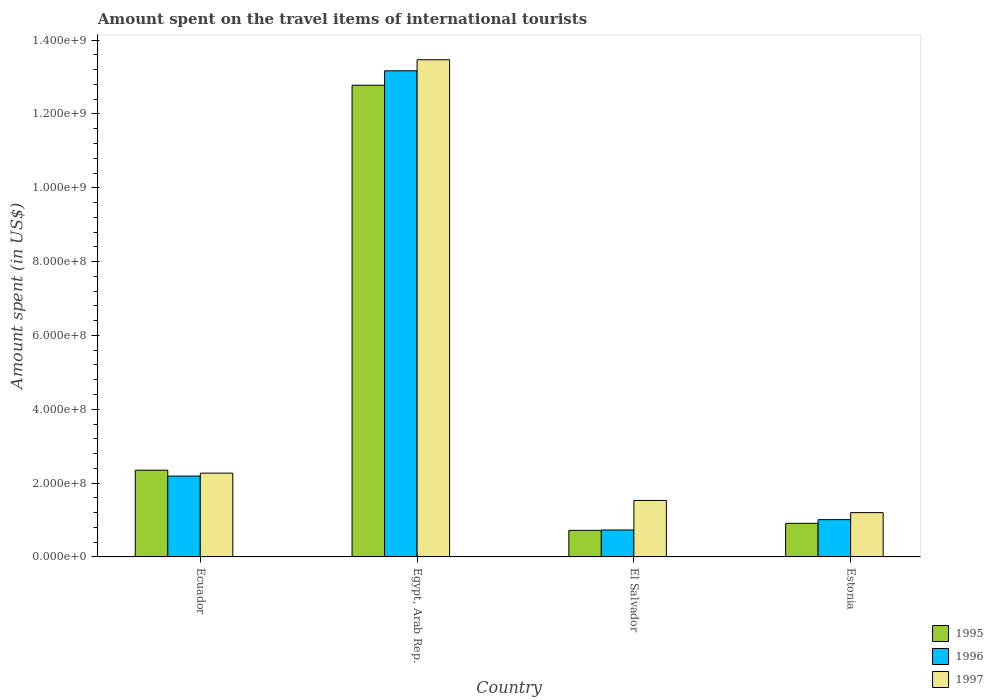How many different coloured bars are there?
Ensure brevity in your answer.  3. How many groups of bars are there?
Your response must be concise. 4. How many bars are there on the 2nd tick from the left?
Your response must be concise. 3. What is the label of the 2nd group of bars from the left?
Keep it short and to the point. Egypt, Arab Rep. In how many cases, is the number of bars for a given country not equal to the number of legend labels?
Keep it short and to the point. 0. What is the amount spent on the travel items of international tourists in 1997 in Egypt, Arab Rep.?
Ensure brevity in your answer.  1.35e+09. Across all countries, what is the maximum amount spent on the travel items of international tourists in 1997?
Make the answer very short. 1.35e+09. Across all countries, what is the minimum amount spent on the travel items of international tourists in 1995?
Give a very brief answer. 7.20e+07. In which country was the amount spent on the travel items of international tourists in 1997 maximum?
Your answer should be very brief. Egypt, Arab Rep. In which country was the amount spent on the travel items of international tourists in 1996 minimum?
Keep it short and to the point. El Salvador. What is the total amount spent on the travel items of international tourists in 1995 in the graph?
Offer a very short reply. 1.68e+09. What is the difference between the amount spent on the travel items of international tourists in 1995 in Egypt, Arab Rep. and that in Estonia?
Your response must be concise. 1.19e+09. What is the difference between the amount spent on the travel items of international tourists in 1996 in Egypt, Arab Rep. and the amount spent on the travel items of international tourists in 1997 in Ecuador?
Ensure brevity in your answer.  1.09e+09. What is the average amount spent on the travel items of international tourists in 1995 per country?
Your answer should be compact. 4.19e+08. What is the difference between the amount spent on the travel items of international tourists of/in 1995 and amount spent on the travel items of international tourists of/in 1997 in El Salvador?
Provide a succinct answer. -8.10e+07. In how many countries, is the amount spent on the travel items of international tourists in 1995 greater than 280000000 US$?
Give a very brief answer. 1. What is the ratio of the amount spent on the travel items of international tourists in 1996 in Ecuador to that in El Salvador?
Provide a succinct answer. 3. Is the amount spent on the travel items of international tourists in 1996 in Ecuador less than that in El Salvador?
Provide a short and direct response. No. Is the difference between the amount spent on the travel items of international tourists in 1995 in Egypt, Arab Rep. and El Salvador greater than the difference between the amount spent on the travel items of international tourists in 1997 in Egypt, Arab Rep. and El Salvador?
Make the answer very short. Yes. What is the difference between the highest and the second highest amount spent on the travel items of international tourists in 1995?
Make the answer very short. 1.19e+09. What is the difference between the highest and the lowest amount spent on the travel items of international tourists in 1996?
Provide a short and direct response. 1.24e+09. Is the sum of the amount spent on the travel items of international tourists in 1997 in Ecuador and Egypt, Arab Rep. greater than the maximum amount spent on the travel items of international tourists in 1996 across all countries?
Provide a succinct answer. Yes. Are all the bars in the graph horizontal?
Offer a terse response. No. How many countries are there in the graph?
Offer a very short reply. 4. Does the graph contain any zero values?
Keep it short and to the point. No. What is the title of the graph?
Provide a short and direct response. Amount spent on the travel items of international tourists. Does "1993" appear as one of the legend labels in the graph?
Keep it short and to the point. No. What is the label or title of the Y-axis?
Your answer should be very brief. Amount spent (in US$). What is the Amount spent (in US$) in 1995 in Ecuador?
Keep it short and to the point. 2.35e+08. What is the Amount spent (in US$) of 1996 in Ecuador?
Provide a short and direct response. 2.19e+08. What is the Amount spent (in US$) in 1997 in Ecuador?
Provide a succinct answer. 2.27e+08. What is the Amount spent (in US$) in 1995 in Egypt, Arab Rep.?
Your response must be concise. 1.28e+09. What is the Amount spent (in US$) in 1996 in Egypt, Arab Rep.?
Offer a very short reply. 1.32e+09. What is the Amount spent (in US$) in 1997 in Egypt, Arab Rep.?
Provide a short and direct response. 1.35e+09. What is the Amount spent (in US$) of 1995 in El Salvador?
Ensure brevity in your answer.  7.20e+07. What is the Amount spent (in US$) in 1996 in El Salvador?
Offer a terse response. 7.30e+07. What is the Amount spent (in US$) of 1997 in El Salvador?
Ensure brevity in your answer.  1.53e+08. What is the Amount spent (in US$) in 1995 in Estonia?
Offer a very short reply. 9.10e+07. What is the Amount spent (in US$) of 1996 in Estonia?
Ensure brevity in your answer.  1.01e+08. What is the Amount spent (in US$) of 1997 in Estonia?
Ensure brevity in your answer.  1.20e+08. Across all countries, what is the maximum Amount spent (in US$) of 1995?
Provide a short and direct response. 1.28e+09. Across all countries, what is the maximum Amount spent (in US$) in 1996?
Give a very brief answer. 1.32e+09. Across all countries, what is the maximum Amount spent (in US$) in 1997?
Offer a very short reply. 1.35e+09. Across all countries, what is the minimum Amount spent (in US$) in 1995?
Provide a succinct answer. 7.20e+07. Across all countries, what is the minimum Amount spent (in US$) of 1996?
Give a very brief answer. 7.30e+07. Across all countries, what is the minimum Amount spent (in US$) of 1997?
Offer a terse response. 1.20e+08. What is the total Amount spent (in US$) of 1995 in the graph?
Your answer should be compact. 1.68e+09. What is the total Amount spent (in US$) in 1996 in the graph?
Your answer should be very brief. 1.71e+09. What is the total Amount spent (in US$) in 1997 in the graph?
Keep it short and to the point. 1.85e+09. What is the difference between the Amount spent (in US$) in 1995 in Ecuador and that in Egypt, Arab Rep.?
Provide a short and direct response. -1.04e+09. What is the difference between the Amount spent (in US$) of 1996 in Ecuador and that in Egypt, Arab Rep.?
Your answer should be compact. -1.10e+09. What is the difference between the Amount spent (in US$) in 1997 in Ecuador and that in Egypt, Arab Rep.?
Ensure brevity in your answer.  -1.12e+09. What is the difference between the Amount spent (in US$) in 1995 in Ecuador and that in El Salvador?
Ensure brevity in your answer.  1.63e+08. What is the difference between the Amount spent (in US$) in 1996 in Ecuador and that in El Salvador?
Make the answer very short. 1.46e+08. What is the difference between the Amount spent (in US$) of 1997 in Ecuador and that in El Salvador?
Keep it short and to the point. 7.40e+07. What is the difference between the Amount spent (in US$) in 1995 in Ecuador and that in Estonia?
Offer a terse response. 1.44e+08. What is the difference between the Amount spent (in US$) of 1996 in Ecuador and that in Estonia?
Provide a succinct answer. 1.18e+08. What is the difference between the Amount spent (in US$) in 1997 in Ecuador and that in Estonia?
Give a very brief answer. 1.07e+08. What is the difference between the Amount spent (in US$) of 1995 in Egypt, Arab Rep. and that in El Salvador?
Provide a short and direct response. 1.21e+09. What is the difference between the Amount spent (in US$) of 1996 in Egypt, Arab Rep. and that in El Salvador?
Make the answer very short. 1.24e+09. What is the difference between the Amount spent (in US$) in 1997 in Egypt, Arab Rep. and that in El Salvador?
Make the answer very short. 1.19e+09. What is the difference between the Amount spent (in US$) in 1995 in Egypt, Arab Rep. and that in Estonia?
Provide a short and direct response. 1.19e+09. What is the difference between the Amount spent (in US$) in 1996 in Egypt, Arab Rep. and that in Estonia?
Give a very brief answer. 1.22e+09. What is the difference between the Amount spent (in US$) in 1997 in Egypt, Arab Rep. and that in Estonia?
Provide a succinct answer. 1.23e+09. What is the difference between the Amount spent (in US$) in 1995 in El Salvador and that in Estonia?
Offer a terse response. -1.90e+07. What is the difference between the Amount spent (in US$) in 1996 in El Salvador and that in Estonia?
Provide a short and direct response. -2.80e+07. What is the difference between the Amount spent (in US$) of 1997 in El Salvador and that in Estonia?
Your response must be concise. 3.30e+07. What is the difference between the Amount spent (in US$) in 1995 in Ecuador and the Amount spent (in US$) in 1996 in Egypt, Arab Rep.?
Give a very brief answer. -1.08e+09. What is the difference between the Amount spent (in US$) in 1995 in Ecuador and the Amount spent (in US$) in 1997 in Egypt, Arab Rep.?
Provide a succinct answer. -1.11e+09. What is the difference between the Amount spent (in US$) of 1996 in Ecuador and the Amount spent (in US$) of 1997 in Egypt, Arab Rep.?
Offer a very short reply. -1.13e+09. What is the difference between the Amount spent (in US$) of 1995 in Ecuador and the Amount spent (in US$) of 1996 in El Salvador?
Provide a succinct answer. 1.62e+08. What is the difference between the Amount spent (in US$) of 1995 in Ecuador and the Amount spent (in US$) of 1997 in El Salvador?
Provide a succinct answer. 8.20e+07. What is the difference between the Amount spent (in US$) of 1996 in Ecuador and the Amount spent (in US$) of 1997 in El Salvador?
Give a very brief answer. 6.60e+07. What is the difference between the Amount spent (in US$) in 1995 in Ecuador and the Amount spent (in US$) in 1996 in Estonia?
Your response must be concise. 1.34e+08. What is the difference between the Amount spent (in US$) in 1995 in Ecuador and the Amount spent (in US$) in 1997 in Estonia?
Your answer should be compact. 1.15e+08. What is the difference between the Amount spent (in US$) of 1996 in Ecuador and the Amount spent (in US$) of 1997 in Estonia?
Your answer should be very brief. 9.90e+07. What is the difference between the Amount spent (in US$) of 1995 in Egypt, Arab Rep. and the Amount spent (in US$) of 1996 in El Salvador?
Give a very brief answer. 1.20e+09. What is the difference between the Amount spent (in US$) in 1995 in Egypt, Arab Rep. and the Amount spent (in US$) in 1997 in El Salvador?
Make the answer very short. 1.12e+09. What is the difference between the Amount spent (in US$) of 1996 in Egypt, Arab Rep. and the Amount spent (in US$) of 1997 in El Salvador?
Ensure brevity in your answer.  1.16e+09. What is the difference between the Amount spent (in US$) of 1995 in Egypt, Arab Rep. and the Amount spent (in US$) of 1996 in Estonia?
Your answer should be compact. 1.18e+09. What is the difference between the Amount spent (in US$) in 1995 in Egypt, Arab Rep. and the Amount spent (in US$) in 1997 in Estonia?
Give a very brief answer. 1.16e+09. What is the difference between the Amount spent (in US$) in 1996 in Egypt, Arab Rep. and the Amount spent (in US$) in 1997 in Estonia?
Provide a short and direct response. 1.20e+09. What is the difference between the Amount spent (in US$) in 1995 in El Salvador and the Amount spent (in US$) in 1996 in Estonia?
Your answer should be compact. -2.90e+07. What is the difference between the Amount spent (in US$) of 1995 in El Salvador and the Amount spent (in US$) of 1997 in Estonia?
Offer a very short reply. -4.80e+07. What is the difference between the Amount spent (in US$) in 1996 in El Salvador and the Amount spent (in US$) in 1997 in Estonia?
Make the answer very short. -4.70e+07. What is the average Amount spent (in US$) of 1995 per country?
Your answer should be compact. 4.19e+08. What is the average Amount spent (in US$) of 1996 per country?
Your response must be concise. 4.28e+08. What is the average Amount spent (in US$) of 1997 per country?
Give a very brief answer. 4.62e+08. What is the difference between the Amount spent (in US$) in 1995 and Amount spent (in US$) in 1996 in Ecuador?
Keep it short and to the point. 1.60e+07. What is the difference between the Amount spent (in US$) of 1996 and Amount spent (in US$) of 1997 in Ecuador?
Keep it short and to the point. -8.00e+06. What is the difference between the Amount spent (in US$) of 1995 and Amount spent (in US$) of 1996 in Egypt, Arab Rep.?
Ensure brevity in your answer.  -3.90e+07. What is the difference between the Amount spent (in US$) in 1995 and Amount spent (in US$) in 1997 in Egypt, Arab Rep.?
Give a very brief answer. -6.90e+07. What is the difference between the Amount spent (in US$) of 1996 and Amount spent (in US$) of 1997 in Egypt, Arab Rep.?
Provide a succinct answer. -3.00e+07. What is the difference between the Amount spent (in US$) in 1995 and Amount spent (in US$) in 1997 in El Salvador?
Keep it short and to the point. -8.10e+07. What is the difference between the Amount spent (in US$) of 1996 and Amount spent (in US$) of 1997 in El Salvador?
Your answer should be very brief. -8.00e+07. What is the difference between the Amount spent (in US$) of 1995 and Amount spent (in US$) of 1996 in Estonia?
Your answer should be very brief. -1.00e+07. What is the difference between the Amount spent (in US$) of 1995 and Amount spent (in US$) of 1997 in Estonia?
Your response must be concise. -2.90e+07. What is the difference between the Amount spent (in US$) of 1996 and Amount spent (in US$) of 1997 in Estonia?
Your response must be concise. -1.90e+07. What is the ratio of the Amount spent (in US$) in 1995 in Ecuador to that in Egypt, Arab Rep.?
Provide a short and direct response. 0.18. What is the ratio of the Amount spent (in US$) in 1996 in Ecuador to that in Egypt, Arab Rep.?
Offer a terse response. 0.17. What is the ratio of the Amount spent (in US$) of 1997 in Ecuador to that in Egypt, Arab Rep.?
Provide a short and direct response. 0.17. What is the ratio of the Amount spent (in US$) of 1995 in Ecuador to that in El Salvador?
Keep it short and to the point. 3.26. What is the ratio of the Amount spent (in US$) in 1996 in Ecuador to that in El Salvador?
Provide a succinct answer. 3. What is the ratio of the Amount spent (in US$) in 1997 in Ecuador to that in El Salvador?
Give a very brief answer. 1.48. What is the ratio of the Amount spent (in US$) in 1995 in Ecuador to that in Estonia?
Offer a very short reply. 2.58. What is the ratio of the Amount spent (in US$) in 1996 in Ecuador to that in Estonia?
Your response must be concise. 2.17. What is the ratio of the Amount spent (in US$) of 1997 in Ecuador to that in Estonia?
Make the answer very short. 1.89. What is the ratio of the Amount spent (in US$) in 1995 in Egypt, Arab Rep. to that in El Salvador?
Ensure brevity in your answer.  17.75. What is the ratio of the Amount spent (in US$) in 1996 in Egypt, Arab Rep. to that in El Salvador?
Give a very brief answer. 18.04. What is the ratio of the Amount spent (in US$) of 1997 in Egypt, Arab Rep. to that in El Salvador?
Your answer should be very brief. 8.8. What is the ratio of the Amount spent (in US$) of 1995 in Egypt, Arab Rep. to that in Estonia?
Your answer should be very brief. 14.04. What is the ratio of the Amount spent (in US$) of 1996 in Egypt, Arab Rep. to that in Estonia?
Provide a short and direct response. 13.04. What is the ratio of the Amount spent (in US$) of 1997 in Egypt, Arab Rep. to that in Estonia?
Make the answer very short. 11.22. What is the ratio of the Amount spent (in US$) of 1995 in El Salvador to that in Estonia?
Provide a succinct answer. 0.79. What is the ratio of the Amount spent (in US$) in 1996 in El Salvador to that in Estonia?
Ensure brevity in your answer.  0.72. What is the ratio of the Amount spent (in US$) in 1997 in El Salvador to that in Estonia?
Make the answer very short. 1.27. What is the difference between the highest and the second highest Amount spent (in US$) in 1995?
Provide a succinct answer. 1.04e+09. What is the difference between the highest and the second highest Amount spent (in US$) in 1996?
Offer a very short reply. 1.10e+09. What is the difference between the highest and the second highest Amount spent (in US$) of 1997?
Ensure brevity in your answer.  1.12e+09. What is the difference between the highest and the lowest Amount spent (in US$) in 1995?
Your answer should be compact. 1.21e+09. What is the difference between the highest and the lowest Amount spent (in US$) in 1996?
Offer a very short reply. 1.24e+09. What is the difference between the highest and the lowest Amount spent (in US$) in 1997?
Offer a terse response. 1.23e+09. 